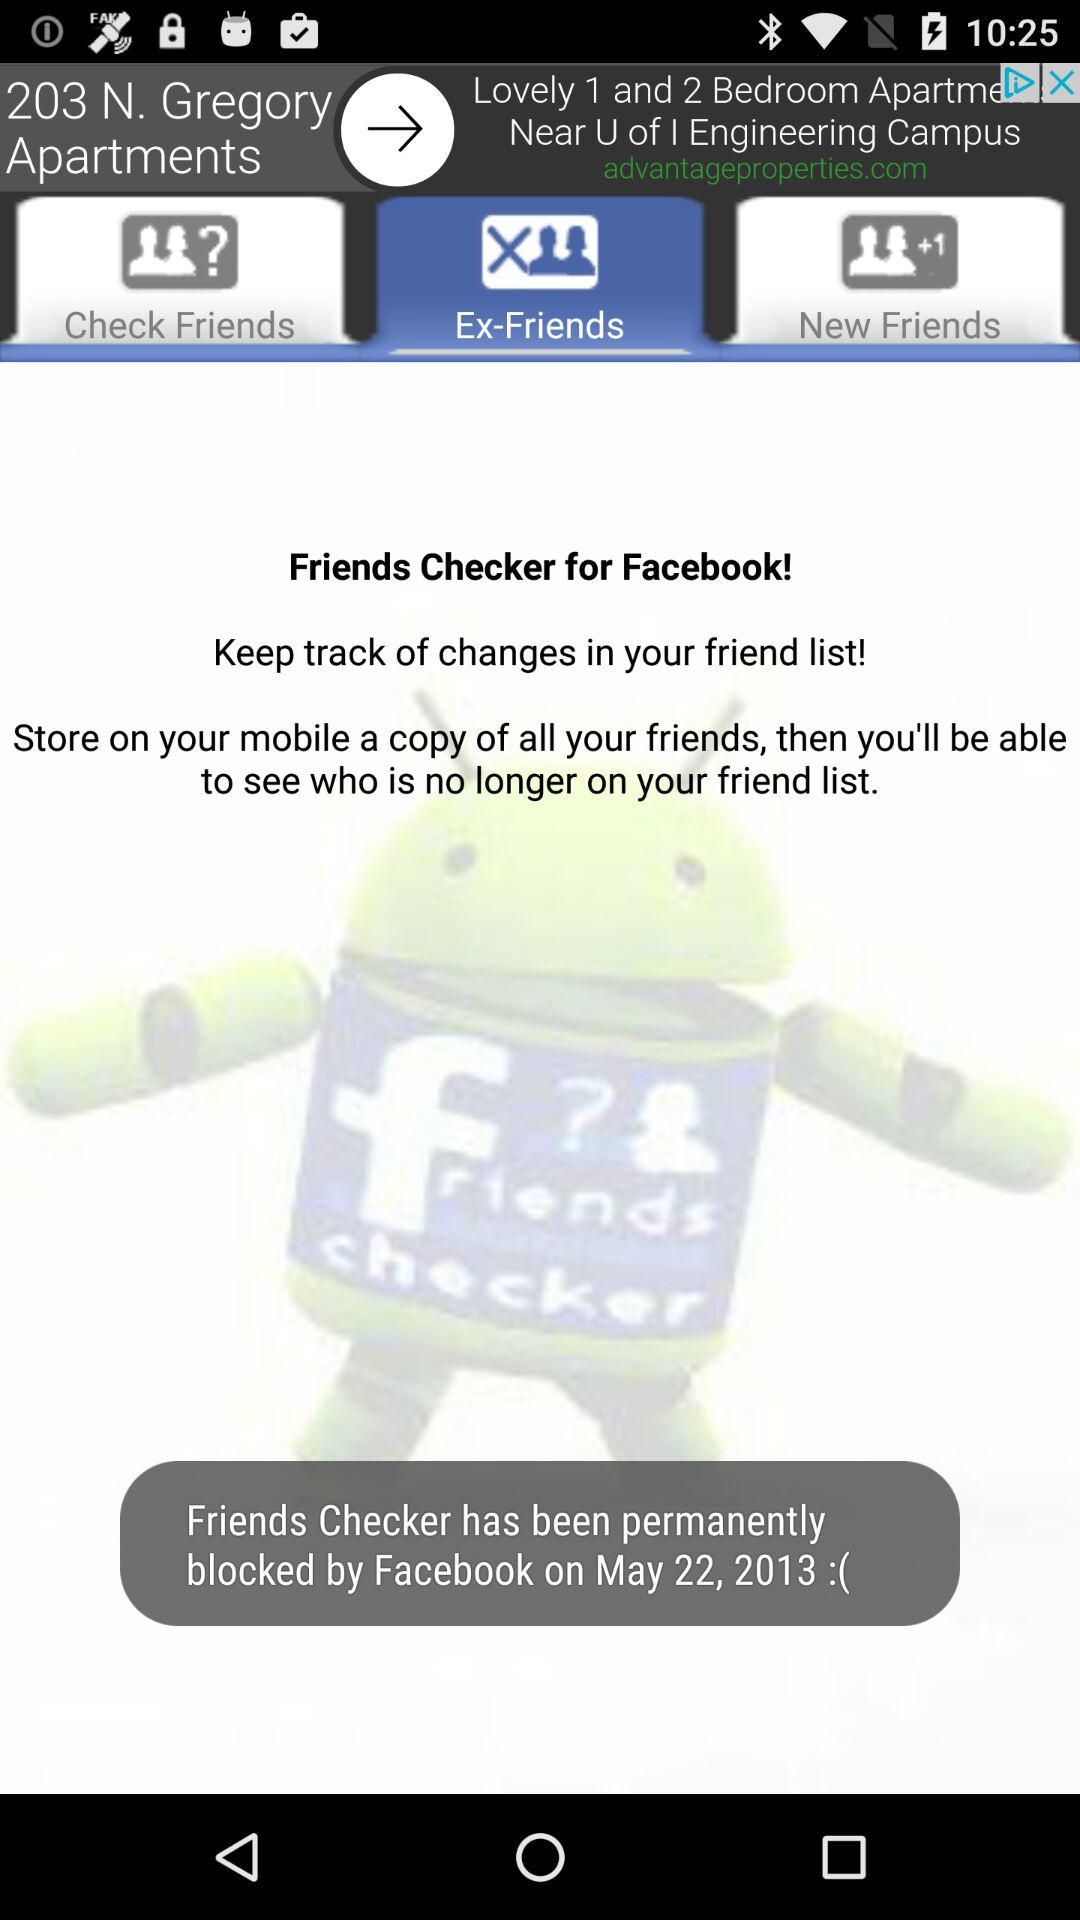What is the name of the application? The name of the application is "Friends Checker". 